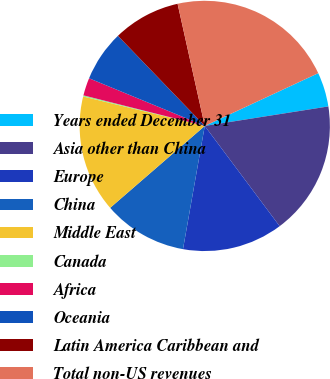Convert chart. <chart><loc_0><loc_0><loc_500><loc_500><pie_chart><fcel>Years ended December 31<fcel>Asia other than China<fcel>Europe<fcel>China<fcel>Middle East<fcel>Canada<fcel>Africa<fcel>Oceania<fcel>Latin America Caribbean and<fcel>Total non-US revenues<nl><fcel>4.44%<fcel>17.28%<fcel>13.0%<fcel>10.86%<fcel>15.14%<fcel>0.15%<fcel>2.29%<fcel>6.58%<fcel>8.72%<fcel>21.56%<nl></chart> 